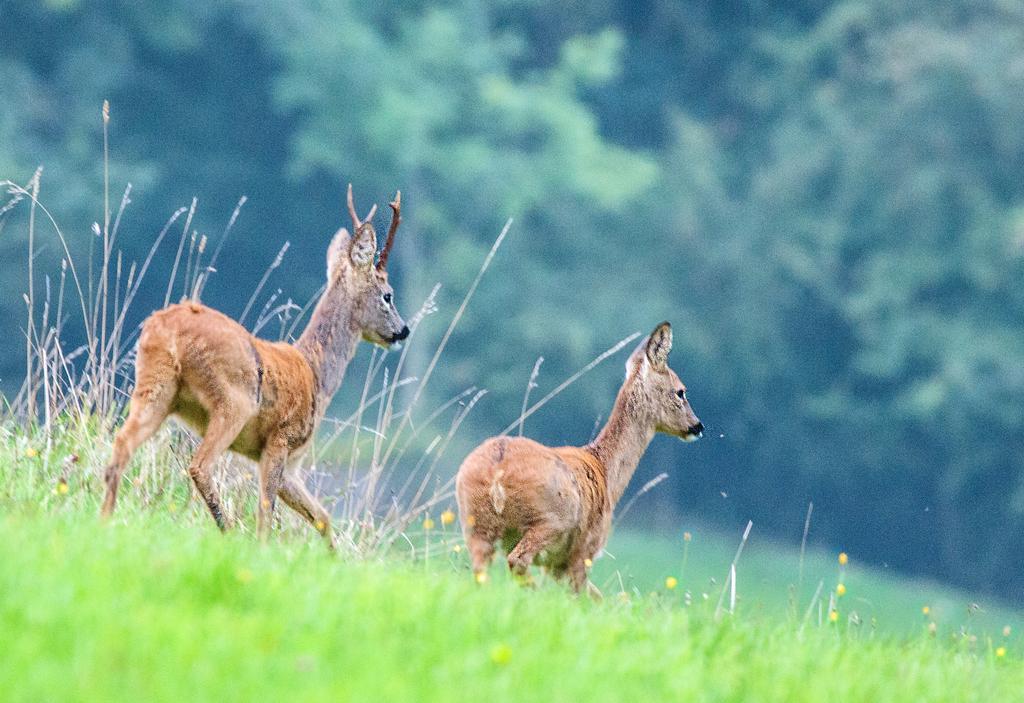Can you describe this image briefly? In this picture I can see two small tears on the ground. At the bottom I can see some yellow flowers on the grass. In the background I can see many trees. 